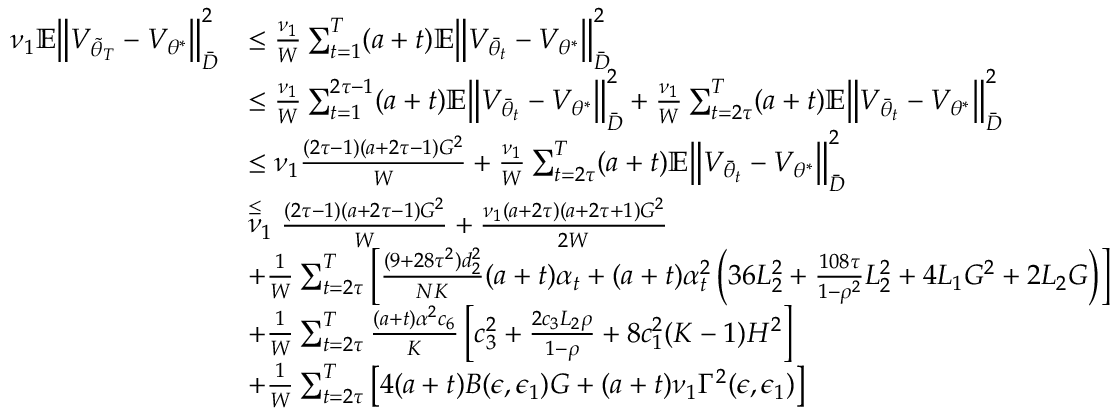<formula> <loc_0><loc_0><loc_500><loc_500>\begin{array} { r l } { \nu _ { 1 } \mathbb { E } \left \| V _ { \tilde { \theta } _ { T } } - V _ { \theta ^ { * } } \right \| _ { \bar { D } } ^ { 2 } } & { \leq \frac { \nu _ { 1 } } { W } \sum _ { t = 1 } ^ { T } ( a + t ) \mathbb { E } \left \| V _ { \bar { \theta } _ { t } } - V _ { \theta ^ { * } } \right \| _ { \bar { D } } ^ { 2 } } \\ & { \leq \frac { \nu _ { 1 } } { W } \sum _ { t = 1 } ^ { 2 \tau - 1 } ( a + t ) \mathbb { E } \left \| V _ { \bar { \theta } _ { t } } - V _ { \theta ^ { * } } \right \| _ { \bar { D } } ^ { 2 } + \frac { \nu _ { 1 } } { W } \sum _ { t = 2 \tau } ^ { T } ( a + t ) \mathbb { E } \left \| V _ { \bar { \theta } _ { t } } - V _ { \theta ^ { * } } \right \| _ { \bar { D } } ^ { 2 } } \\ & { \leq \nu _ { 1 } \frac { ( 2 \tau - 1 ) ( a + 2 \tau - 1 ) G ^ { 2 } } { W } + \frac { \nu _ { 1 } } { W } \sum _ { t = 2 \tau } ^ { T } ( a + t ) \mathbb { E } \left \| V _ { \bar { \theta } _ { t } } - V _ { \theta ^ { * } } \right \| _ { \bar { D } } ^ { 2 } } \\ & { \stackrel { \leq } \nu _ { 1 } \frac { ( 2 \tau - 1 ) ( a + 2 \tau - 1 ) G ^ { 2 } } { W } + \frac { \nu _ { 1 } ( a + 2 \tau ) ( a + 2 \tau + 1 ) G ^ { 2 } } { 2 W } } \\ & { + \frac { 1 } { W } \sum _ { t = 2 \tau } ^ { T } \left [ \frac { ( 9 + 2 8 \tau ^ { 2 } ) d _ { 2 } ^ { 2 } } { N K } ( a + t ) \alpha _ { t } + ( a + t ) \alpha _ { t } ^ { 2 } \left ( 3 6 L _ { 2 } ^ { 2 } + \frac { 1 0 8 \tau } { 1 - \rho ^ { 2 } } L _ { 2 } ^ { 2 } + 4 L _ { 1 } G ^ { 2 } + 2 L _ { 2 } G \right ) \right ] } \\ & { + \frac { 1 } { W } \sum _ { t = 2 \tau } ^ { T } \frac { ( a + t ) \alpha ^ { 2 } c _ { 6 } } { K } \left [ c _ { 3 } ^ { 2 } + \frac { 2 c _ { 3 } L _ { 2 } \rho } { 1 - \rho } + 8 c _ { 1 } ^ { 2 } ( K - 1 ) H ^ { 2 } \right ] } \\ & { + \frac { 1 } { W } \sum _ { t = 2 \tau } ^ { T } \left [ 4 ( a + t ) B ( \epsilon , \epsilon _ { 1 } ) G + ( a + t ) \nu _ { 1 } \Gamma ^ { 2 } ( \epsilon , \epsilon _ { 1 } ) \right ] } \end{array}</formula> 